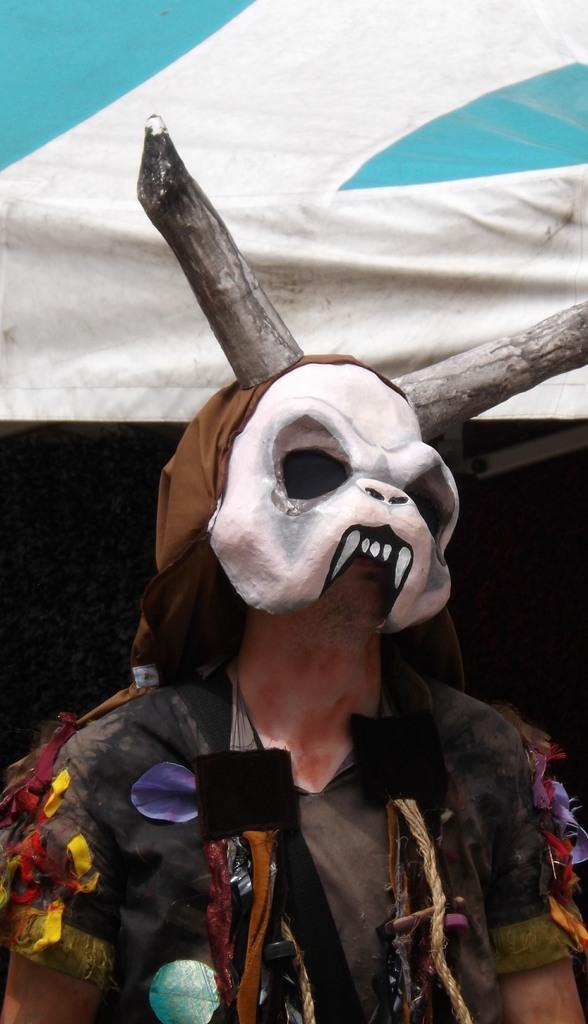Could you give a brief overview of what you see in this image? In this image in front there is a person wearing a mask. Behind him there is a tent. 